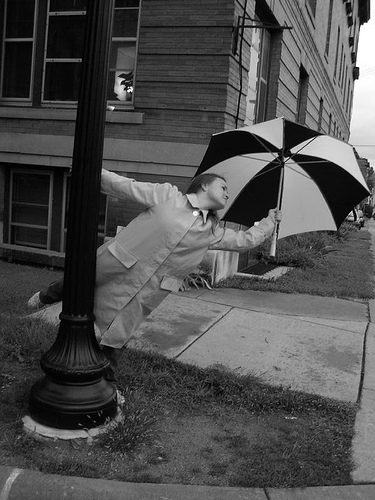<image>What movie is the man copying? I am not sure what movie the man is copying. It could be 'Mary Poppins', 'Singing in the Rain' or "It's a Wonderful Life". What movie is the man copying? I don't know what movie the man is copying. It can be 'mary poppins', 'singing in rain' or "it's wonderful life". 